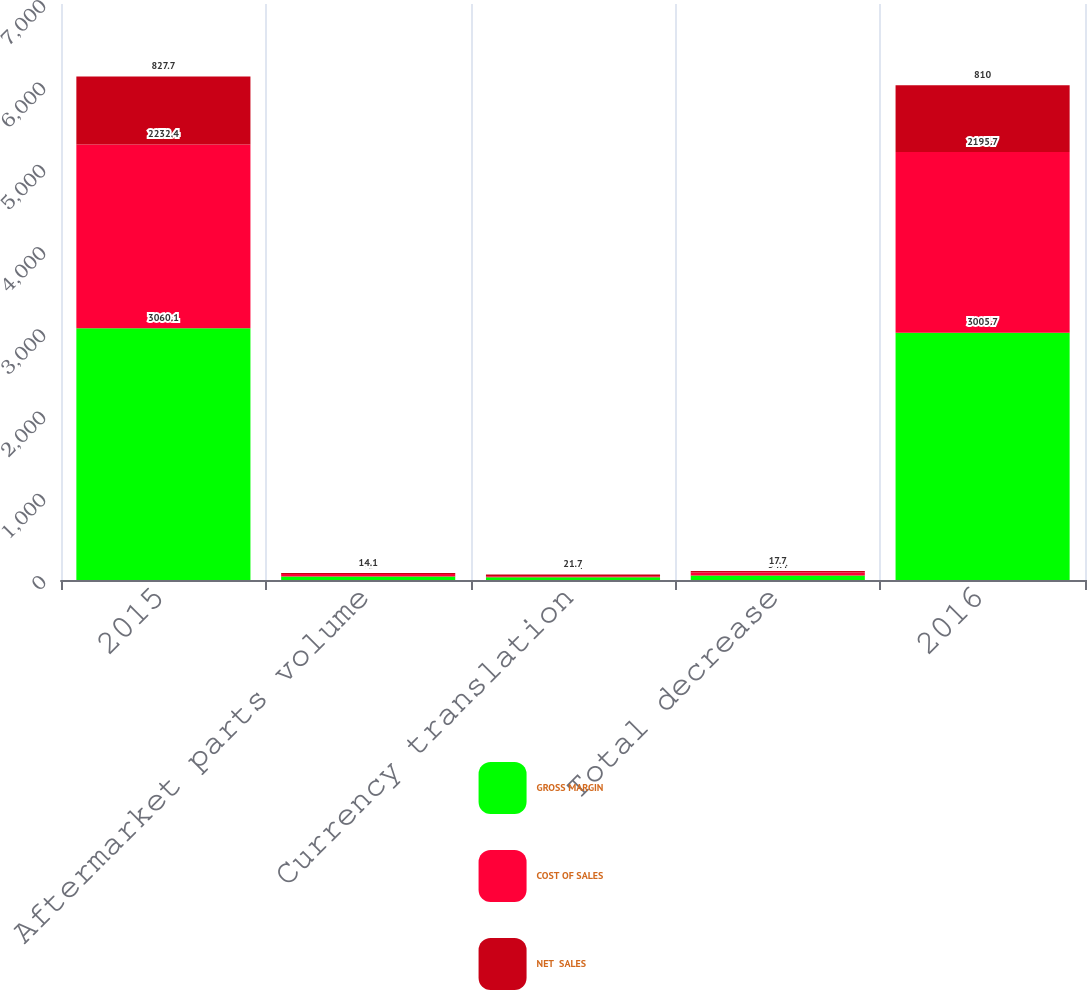<chart> <loc_0><loc_0><loc_500><loc_500><stacked_bar_chart><ecel><fcel>2015<fcel>Aftermarket parts volume<fcel>Currency translation<fcel>Total decrease<fcel>2016<nl><fcel>GROSS MARGIN<fcel>3060.1<fcel>43<fcel>33.9<fcel>54.4<fcel>3005.7<nl><fcel>COST OF SALES<fcel>2232.4<fcel>28.9<fcel>12.2<fcel>36.7<fcel>2195.7<nl><fcel>NET  SALES<fcel>827.7<fcel>14.1<fcel>21.7<fcel>17.7<fcel>810<nl></chart> 